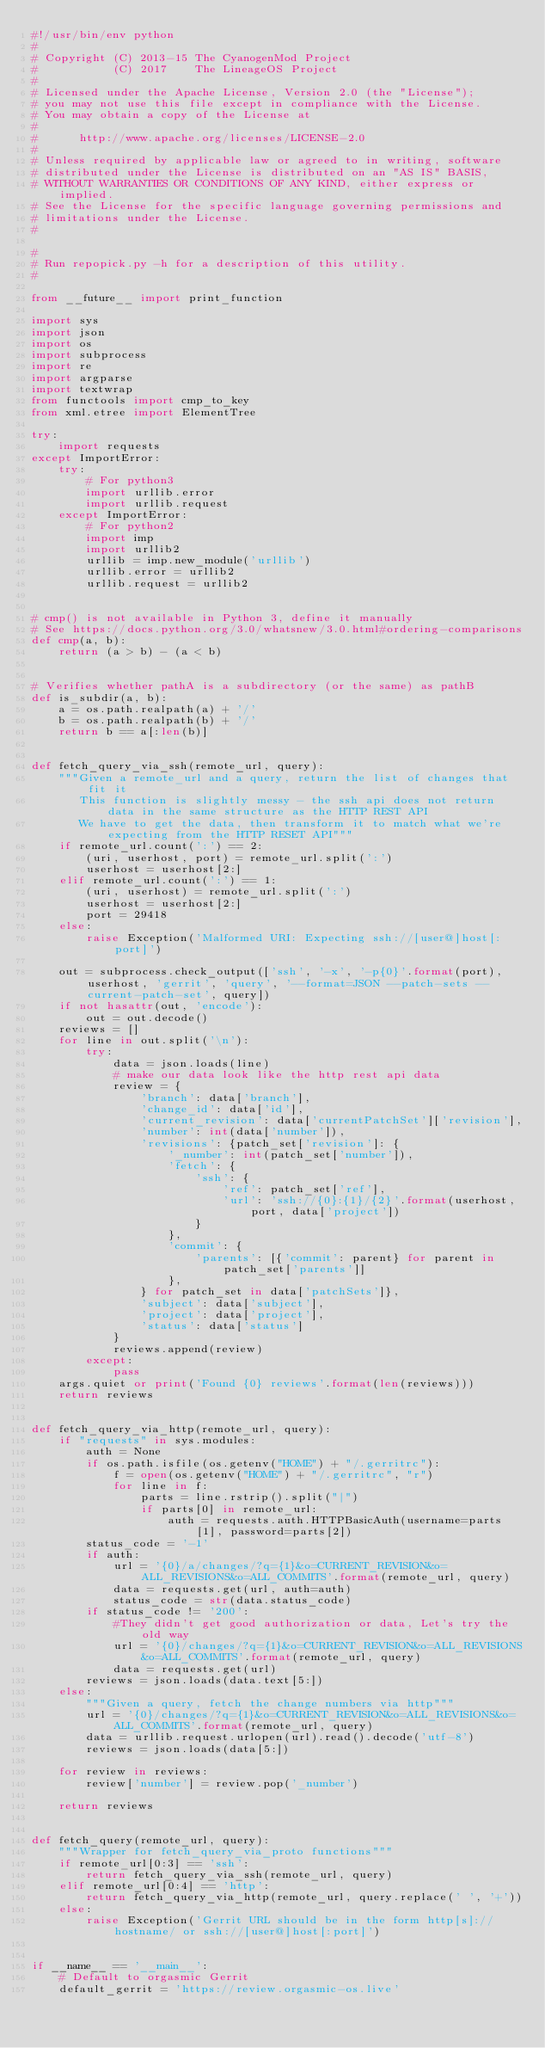<code> <loc_0><loc_0><loc_500><loc_500><_Python_>#!/usr/bin/env python
#
# Copyright (C) 2013-15 The CyanogenMod Project
#           (C) 2017    The LineageOS Project
#
# Licensed under the Apache License, Version 2.0 (the "License");
# you may not use this file except in compliance with the License.
# You may obtain a copy of the License at
#
#      http://www.apache.org/licenses/LICENSE-2.0
#
# Unless required by applicable law or agreed to in writing, software
# distributed under the License is distributed on an "AS IS" BASIS,
# WITHOUT WARRANTIES OR CONDITIONS OF ANY KIND, either express or implied.
# See the License for the specific language governing permissions and
# limitations under the License.
#

#
# Run repopick.py -h for a description of this utility.
#

from __future__ import print_function

import sys
import json
import os
import subprocess
import re
import argparse
import textwrap
from functools import cmp_to_key
from xml.etree import ElementTree

try:
    import requests
except ImportError:
    try:
        # For python3
        import urllib.error
        import urllib.request
    except ImportError:
        # For python2
        import imp
        import urllib2
        urllib = imp.new_module('urllib')
        urllib.error = urllib2
        urllib.request = urllib2


# cmp() is not available in Python 3, define it manually
# See https://docs.python.org/3.0/whatsnew/3.0.html#ordering-comparisons
def cmp(a, b):
    return (a > b) - (a < b)


# Verifies whether pathA is a subdirectory (or the same) as pathB
def is_subdir(a, b):
    a = os.path.realpath(a) + '/'
    b = os.path.realpath(b) + '/'
    return b == a[:len(b)]


def fetch_query_via_ssh(remote_url, query):
    """Given a remote_url and a query, return the list of changes that fit it
       This function is slightly messy - the ssh api does not return data in the same structure as the HTTP REST API
       We have to get the data, then transform it to match what we're expecting from the HTTP RESET API"""
    if remote_url.count(':') == 2:
        (uri, userhost, port) = remote_url.split(':')
        userhost = userhost[2:]
    elif remote_url.count(':') == 1:
        (uri, userhost) = remote_url.split(':')
        userhost = userhost[2:]
        port = 29418
    else:
        raise Exception('Malformed URI: Expecting ssh://[user@]host[:port]')

    out = subprocess.check_output(['ssh', '-x', '-p{0}'.format(port), userhost, 'gerrit', 'query', '--format=JSON --patch-sets --current-patch-set', query])
    if not hasattr(out, 'encode'):
        out = out.decode()
    reviews = []
    for line in out.split('\n'):
        try:
            data = json.loads(line)
            # make our data look like the http rest api data
            review = {
                'branch': data['branch'],
                'change_id': data['id'],
                'current_revision': data['currentPatchSet']['revision'],
                'number': int(data['number']),
                'revisions': {patch_set['revision']: {
                    '_number': int(patch_set['number']),
                    'fetch': {
                        'ssh': {
                            'ref': patch_set['ref'],
                            'url': 'ssh://{0}:{1}/{2}'.format(userhost, port, data['project'])
                        }
                    },
                    'commit': {
                        'parents': [{'commit': parent} for parent in patch_set['parents']]
                    },
                } for patch_set in data['patchSets']},
                'subject': data['subject'],
                'project': data['project'],
                'status': data['status']
            }
            reviews.append(review)
        except:
            pass
    args.quiet or print('Found {0} reviews'.format(len(reviews)))
    return reviews


def fetch_query_via_http(remote_url, query):
    if "requests" in sys.modules:
        auth = None
        if os.path.isfile(os.getenv("HOME") + "/.gerritrc"):
            f = open(os.getenv("HOME") + "/.gerritrc", "r")
            for line in f:
                parts = line.rstrip().split("|")
                if parts[0] in remote_url:
                    auth = requests.auth.HTTPBasicAuth(username=parts[1], password=parts[2])
        status_code = '-1'
        if auth:
            url = '{0}/a/changes/?q={1}&o=CURRENT_REVISION&o=ALL_REVISIONS&o=ALL_COMMITS'.format(remote_url, query)
            data = requests.get(url, auth=auth)
            status_code = str(data.status_code)
        if status_code != '200':
            #They didn't get good authorization or data, Let's try the old way
            url = '{0}/changes/?q={1}&o=CURRENT_REVISION&o=ALL_REVISIONS&o=ALL_COMMITS'.format(remote_url, query)
            data = requests.get(url)
        reviews = json.loads(data.text[5:])
    else:
        """Given a query, fetch the change numbers via http"""
        url = '{0}/changes/?q={1}&o=CURRENT_REVISION&o=ALL_REVISIONS&o=ALL_COMMITS'.format(remote_url, query)
        data = urllib.request.urlopen(url).read().decode('utf-8')
        reviews = json.loads(data[5:])

    for review in reviews:
        review['number'] = review.pop('_number')

    return reviews


def fetch_query(remote_url, query):
    """Wrapper for fetch_query_via_proto functions"""
    if remote_url[0:3] == 'ssh':
        return fetch_query_via_ssh(remote_url, query)
    elif remote_url[0:4] == 'http':
        return fetch_query_via_http(remote_url, query.replace(' ', '+'))
    else:
        raise Exception('Gerrit URL should be in the form http[s]://hostname/ or ssh://[user@]host[:port]')


if __name__ == '__main__':
    # Default to orgasmic Gerrit
    default_gerrit = 'https://review.orgasmic-os.live'
</code> 